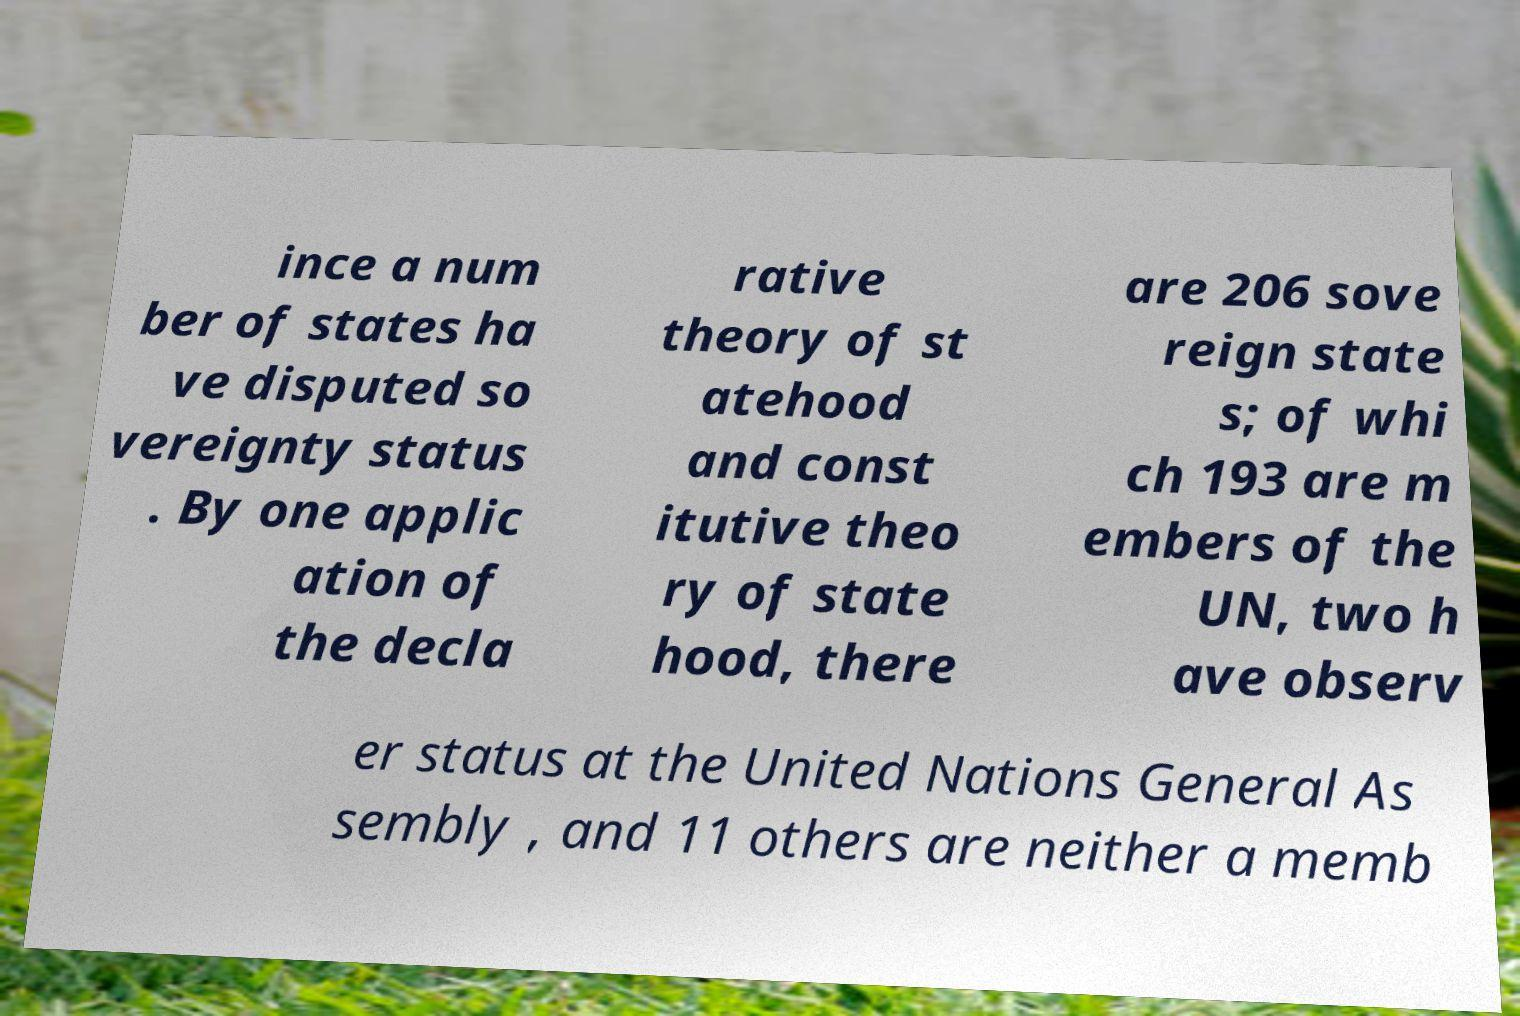Please read and relay the text visible in this image. What does it say? ince a num ber of states ha ve disputed so vereignty status . By one applic ation of the decla rative theory of st atehood and const itutive theo ry of state hood, there are 206 sove reign state s; of whi ch 193 are m embers of the UN, two h ave observ er status at the United Nations General As sembly , and 11 others are neither a memb 